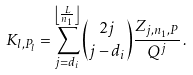Convert formula to latex. <formula><loc_0><loc_0><loc_500><loc_500>K _ { l , P _ { l } } = \sum _ { j = d _ { i } } ^ { \left \lfloor \frac { L } { n _ { 1 } } \right \rfloor } { 2 j \choose j - d _ { i } } \frac { Z _ { j , n _ { 1 } , P } } { Q ^ { j } } \, .</formula> 